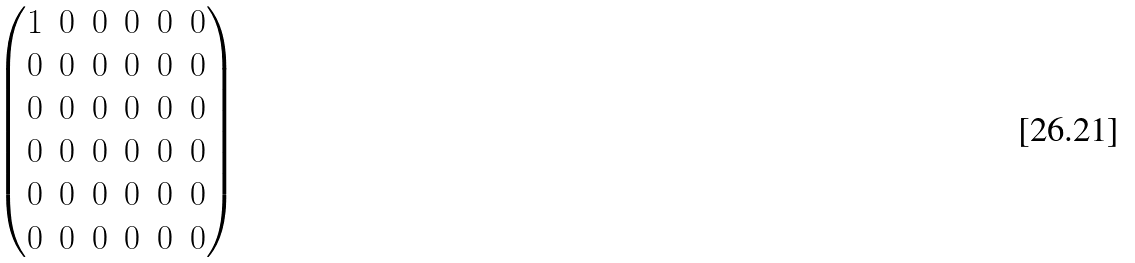Convert formula to latex. <formula><loc_0><loc_0><loc_500><loc_500>\begin{pmatrix} 1 & 0 & 0 & 0 & 0 & 0 \\ 0 & 0 & 0 & 0 & 0 & 0 \\ 0 & 0 & 0 & 0 & 0 & 0 \\ 0 & 0 & 0 & 0 & 0 & 0 \\ 0 & 0 & 0 & 0 & 0 & 0 \\ 0 & 0 & 0 & 0 & 0 & 0 \end{pmatrix}</formula> 